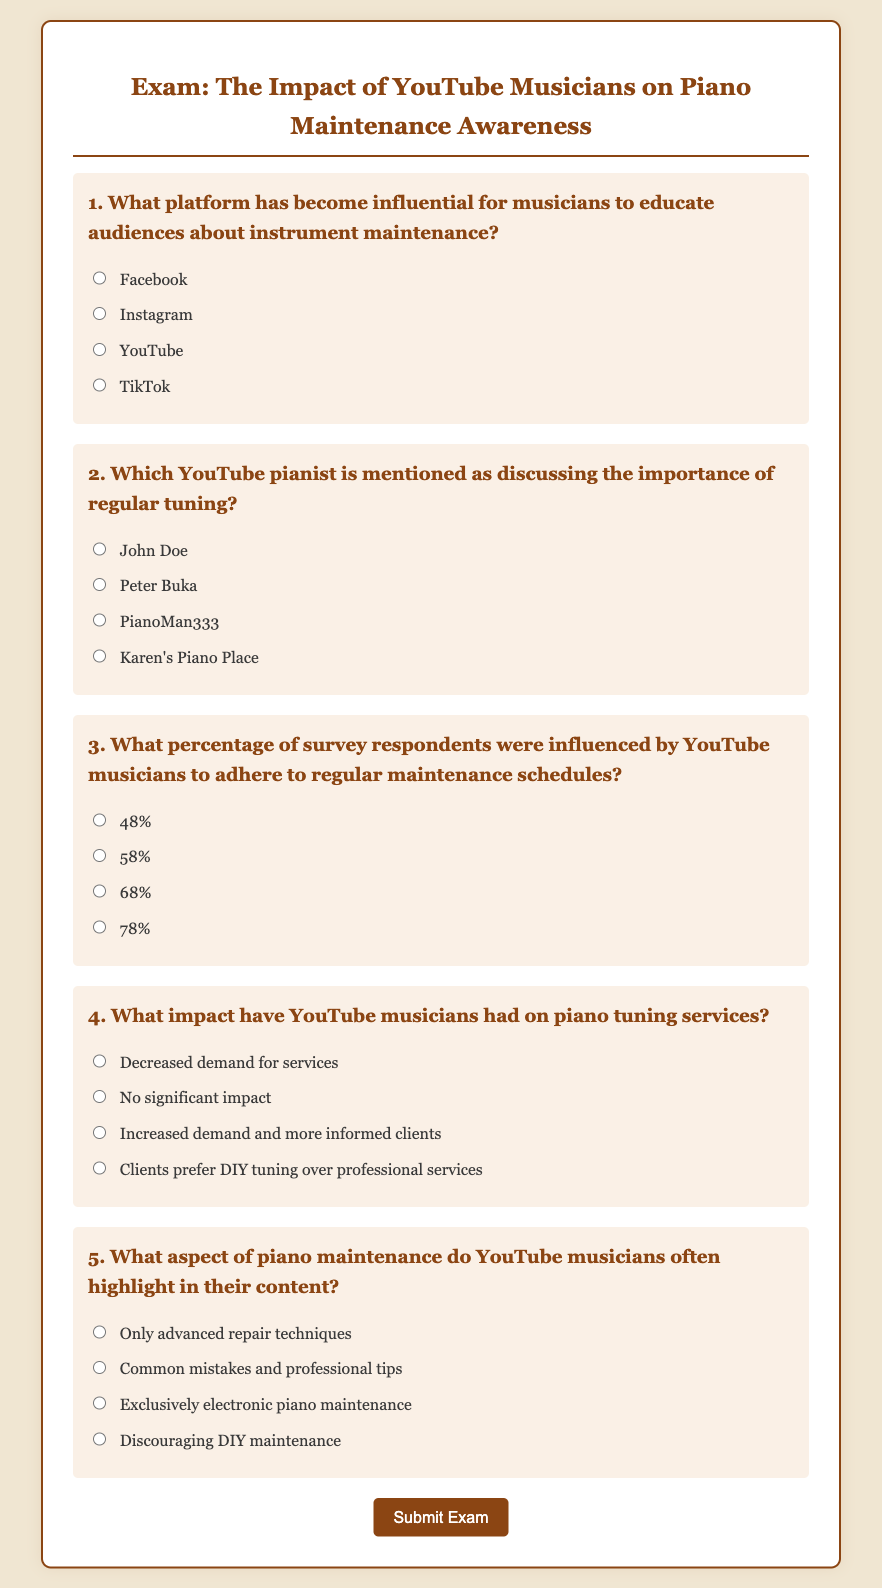What platform has become influential for musicians to educate audiences about instrument maintenance? The document specifies that YouTube has become influential for musicians in educating audiences about instrument maintenance.
Answer: YouTube Which YouTube pianist is mentioned as discussing the importance of regular tuning? The document mentions Peter Buka as a YouTube pianist discussing the importance of regular tuning.
Answer: Peter Buka What percentage of survey respondents were influenced by YouTube musicians to adhere to regular maintenance schedules? According to the document, 58% of survey respondents were influenced by YouTube musicians to adhere to regular maintenance schedules.
Answer: 58% What impact have YouTube musicians had on piano tuning services? The document states that YouTube musicians have increased demand for services and resulted in more informed clients.
Answer: Increased demand and more informed clients What aspect of piano maintenance do YouTube musicians often highlight in their content? The document mentions that YouTube musicians highlight common mistakes and professional tips in their content regarding piano maintenance.
Answer: Common mistakes and professional tips 